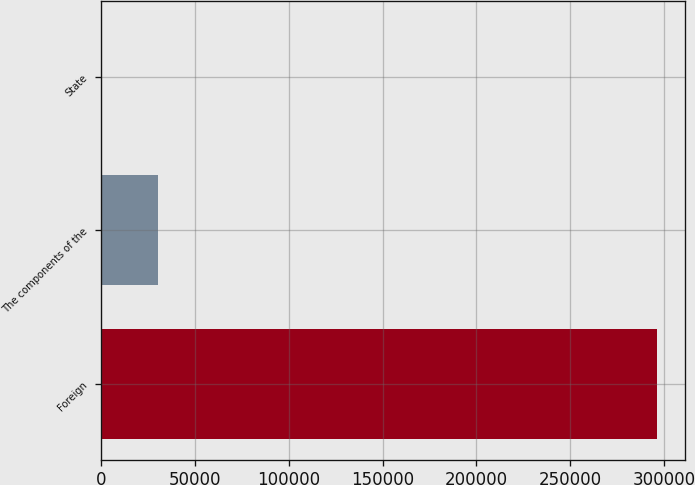Convert chart. <chart><loc_0><loc_0><loc_500><loc_500><bar_chart><fcel>Foreign<fcel>The components of the<fcel>State<nl><fcel>296311<fcel>30193.6<fcel>625<nl></chart> 